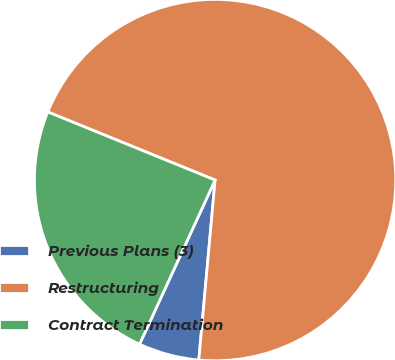Convert chart to OTSL. <chart><loc_0><loc_0><loc_500><loc_500><pie_chart><fcel>Previous Plans (3)<fcel>Restructuring<fcel>Contract Termination<nl><fcel>5.43%<fcel>70.28%<fcel>24.29%<nl></chart> 